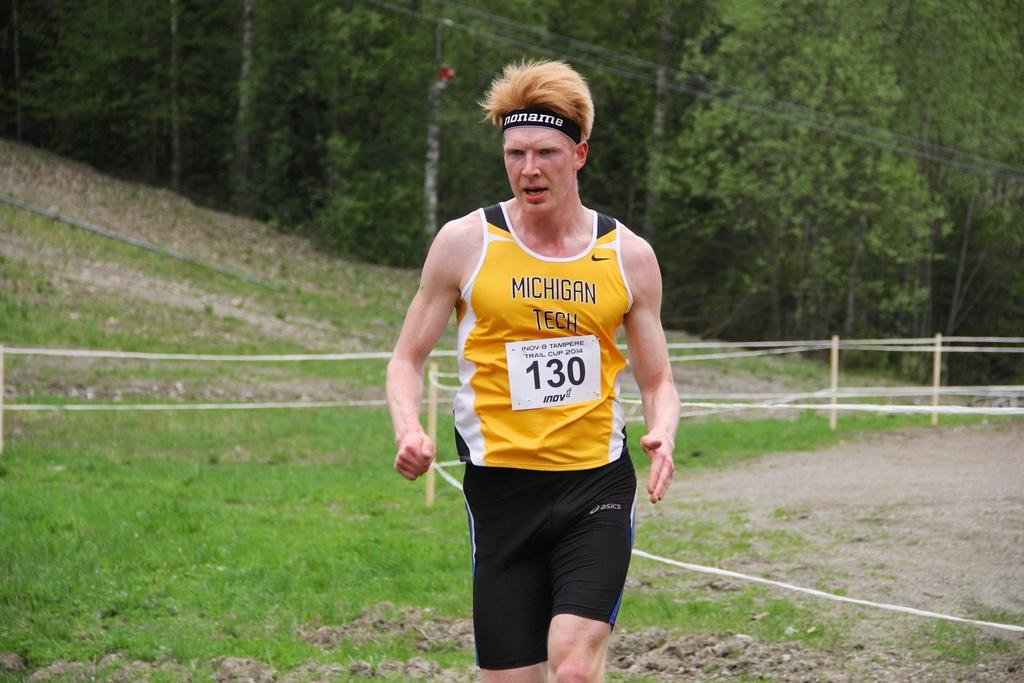<image>
Render a clear and concise summary of the photo. A runner from Michigan Tech donning the number 130. 